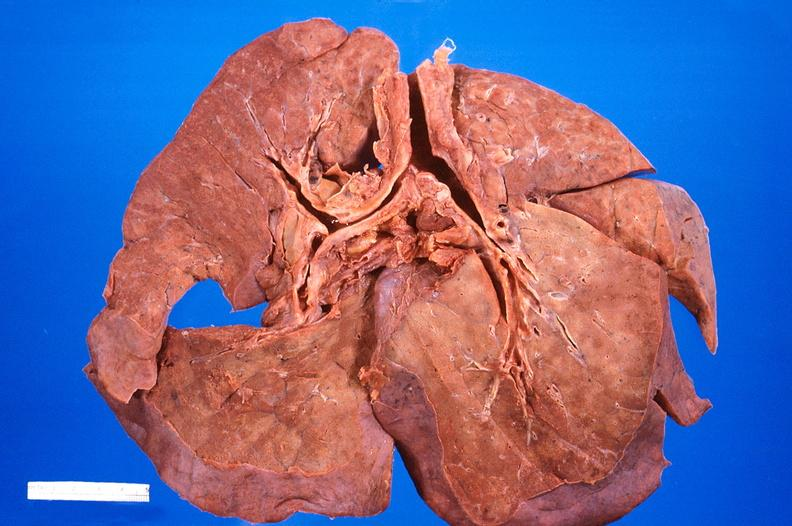what does this image show?
Answer the question using a single word or phrase. Lung 